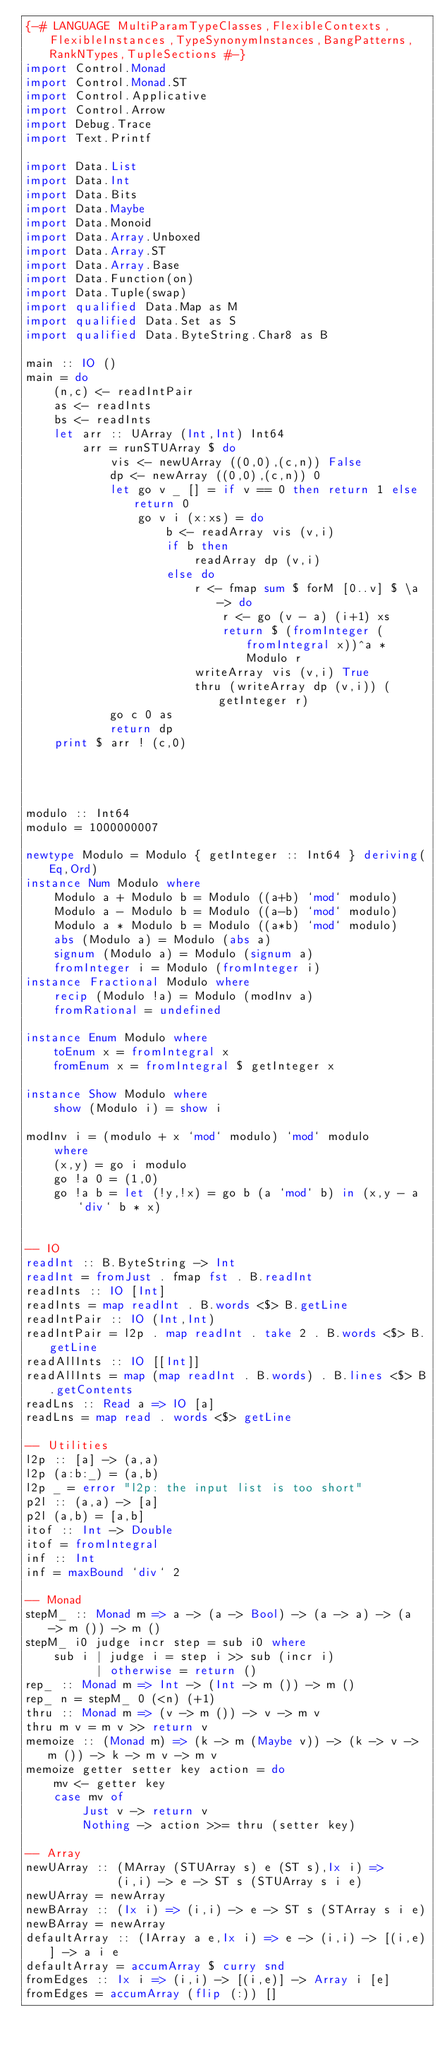<code> <loc_0><loc_0><loc_500><loc_500><_Haskell_>{-# LANGUAGE MultiParamTypeClasses,FlexibleContexts,FlexibleInstances,TypeSynonymInstances,BangPatterns,RankNTypes,TupleSections #-}
import Control.Monad
import Control.Monad.ST
import Control.Applicative
import Control.Arrow
import Debug.Trace
import Text.Printf

import Data.List
import Data.Int
import Data.Bits
import Data.Maybe
import Data.Monoid
import Data.Array.Unboxed
import Data.Array.ST
import Data.Array.Base
import Data.Function(on)
import Data.Tuple(swap)
import qualified Data.Map as M
import qualified Data.Set as S
import qualified Data.ByteString.Char8 as B

main :: IO ()
main = do
    (n,c) <- readIntPair
    as <- readInts
    bs <- readInts
    let arr :: UArray (Int,Int) Int64
        arr = runSTUArray $ do
            vis <- newUArray ((0,0),(c,n)) False
            dp <- newArray ((0,0),(c,n)) 0
            let go v _ [] = if v == 0 then return 1 else return 0
                go v i (x:xs) = do
                    b <- readArray vis (v,i)
                    if b then
                        readArray dp (v,i)
                    else do
                        r <- fmap sum $ forM [0..v] $ \a -> do
                            r <- go (v - a) (i+1) xs
                            return $ (fromInteger (fromIntegral x))^a * Modulo r
                        writeArray vis (v,i) True
                        thru (writeArray dp (v,i)) (getInteger r)
            go c 0 as
            return dp
    print $ arr ! (c,0)




modulo :: Int64
modulo = 1000000007

newtype Modulo = Modulo { getInteger :: Int64 } deriving(Eq,Ord)
instance Num Modulo where
    Modulo a + Modulo b = Modulo ((a+b) `mod` modulo)
    Modulo a - Modulo b = Modulo ((a-b) `mod` modulo)
    Modulo a * Modulo b = Modulo ((a*b) `mod` modulo)
    abs (Modulo a) = Modulo (abs a)
    signum (Modulo a) = Modulo (signum a)
    fromInteger i = Modulo (fromInteger i)
instance Fractional Modulo where
    recip (Modulo !a) = Modulo (modInv a)
    fromRational = undefined

instance Enum Modulo where
    toEnum x = fromIntegral x
    fromEnum x = fromIntegral $ getInteger x

instance Show Modulo where
    show (Modulo i) = show i
 
modInv i = (modulo + x `mod` modulo) `mod` modulo
    where
    (x,y) = go i modulo
    go !a 0 = (1,0)
    go !a b = let (!y,!x) = go b (a `mod` b) in (x,y - a `div` b * x)


-- IO
readInt :: B.ByteString -> Int
readInt = fromJust . fmap fst . B.readInt
readInts :: IO [Int]
readInts = map readInt . B.words <$> B.getLine
readIntPair :: IO (Int,Int)
readIntPair = l2p . map readInt . take 2 . B.words <$> B.getLine
readAllInts :: IO [[Int]]
readAllInts = map (map readInt . B.words) . B.lines <$> B.getContents
readLns :: Read a => IO [a]
readLns = map read . words <$> getLine

-- Utilities
l2p :: [a] -> (a,a)
l2p (a:b:_) = (a,b)
l2p _ = error "l2p: the input list is too short"
p2l :: (a,a) -> [a]
p2l (a,b) = [a,b]
itof :: Int -> Double
itof = fromIntegral
inf :: Int
inf = maxBound `div` 2

-- Monad
stepM_ :: Monad m => a -> (a -> Bool) -> (a -> a) -> (a -> m ()) -> m ()
stepM_ i0 judge incr step = sub i0 where 
    sub i | judge i = step i >> sub (incr i) 
          | otherwise = return ()
rep_ :: Monad m => Int -> (Int -> m ()) -> m ()
rep_ n = stepM_ 0 (<n) (+1)
thru :: Monad m => (v -> m ()) -> v -> m v
thru m v = m v >> return v
memoize :: (Monad m) => (k -> m (Maybe v)) -> (k -> v -> m ()) -> k -> m v -> m v
memoize getter setter key action = do
    mv <- getter key
    case mv of
        Just v -> return v
        Nothing -> action >>= thru (setter key)

-- Array
newUArray :: (MArray (STUArray s) e (ST s),Ix i) => 
             (i,i) -> e -> ST s (STUArray s i e)
newUArray = newArray
newBArray :: (Ix i) => (i,i) -> e -> ST s (STArray s i e)
newBArray = newArray
defaultArray :: (IArray a e,Ix i) => e -> (i,i) -> [(i,e)] -> a i e
defaultArray = accumArray $ curry snd
fromEdges :: Ix i => (i,i) -> [(i,e)] -> Array i [e]
fromEdges = accumArray (flip (:)) []
</code> 